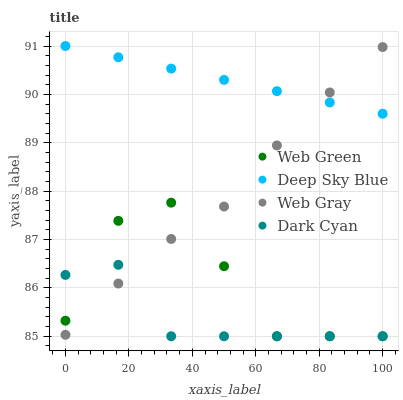Does Dark Cyan have the minimum area under the curve?
Answer yes or no. Yes. Does Deep Sky Blue have the maximum area under the curve?
Answer yes or no. Yes. Does Web Gray have the minimum area under the curve?
Answer yes or no. No. Does Web Gray have the maximum area under the curve?
Answer yes or no. No. Is Deep Sky Blue the smoothest?
Answer yes or no. Yes. Is Web Green the roughest?
Answer yes or no. Yes. Is Web Gray the smoothest?
Answer yes or no. No. Is Web Gray the roughest?
Answer yes or no. No. Does Dark Cyan have the lowest value?
Answer yes or no. Yes. Does Web Gray have the lowest value?
Answer yes or no. No. Does Deep Sky Blue have the highest value?
Answer yes or no. Yes. Does Web Gray have the highest value?
Answer yes or no. No. Is Dark Cyan less than Deep Sky Blue?
Answer yes or no. Yes. Is Deep Sky Blue greater than Dark Cyan?
Answer yes or no. Yes. Does Web Gray intersect Dark Cyan?
Answer yes or no. Yes. Is Web Gray less than Dark Cyan?
Answer yes or no. No. Is Web Gray greater than Dark Cyan?
Answer yes or no. No. Does Dark Cyan intersect Deep Sky Blue?
Answer yes or no. No. 